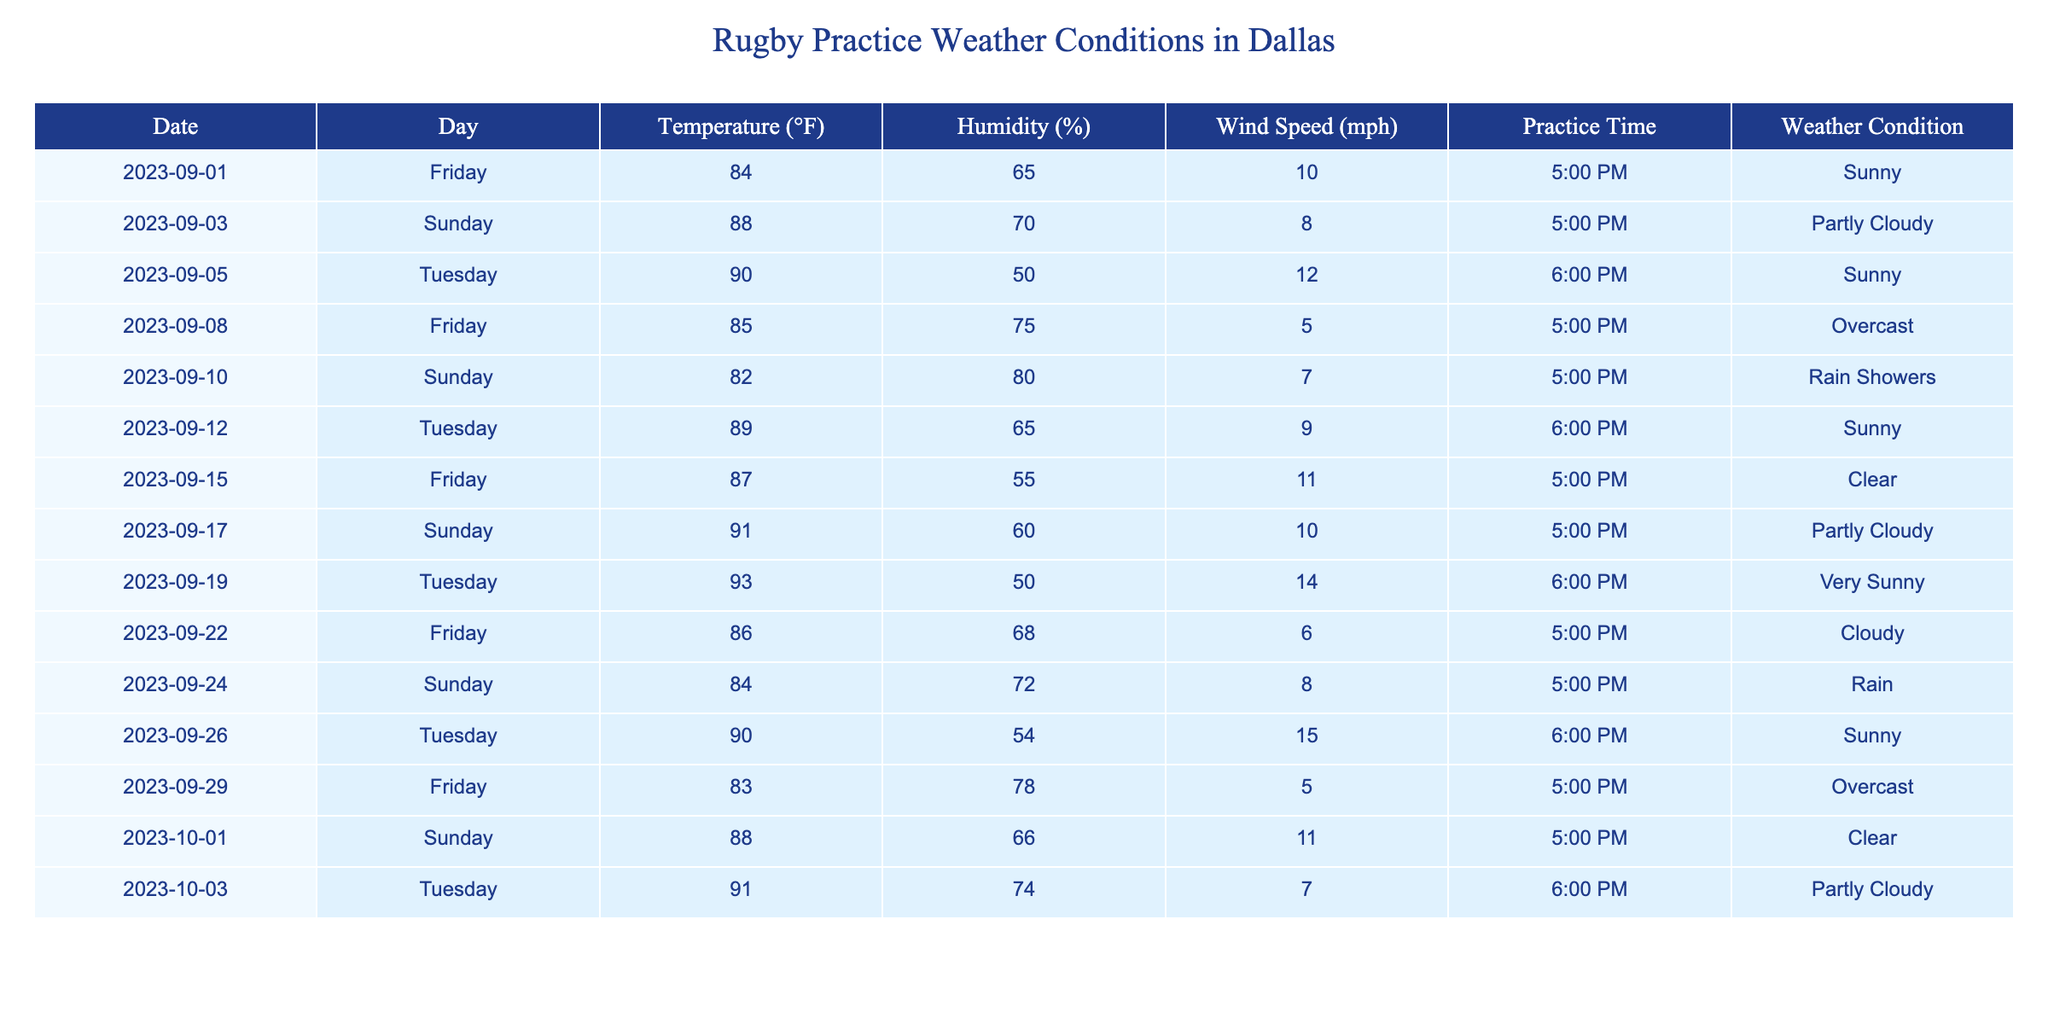What was the highest temperature recorded during rugby practice? The table lists the temperatures for various practice days. The maximum temperature is found by checking each entry, which shows that 93°F on 2023-09-19 was the highest.
Answer: 93°F How many days had rain as a weather condition during practice? Looking through the weather conditions in the table, there are two entries where 'Rain' or 'Rain Showers' is mentioned: 2023-09-10 and 2023-09-24. Hence, the total is two days.
Answer: 2 days What is the average humidity during the practices listed? To calculate the average humidity, sum all humidity values (65 + 70 + 50 + 75 + 80 + 65 + 55 + 60 + 50 + 68 + 72 + 54 + 78 + 66 + 74) which equals 1030 and then divide by the number of entries (15), yielding an average of 68.67%.
Answer: 68.67% Was there any day without wind during practice? By examining the wind speed column, no entries have a wind speed of 0 mph; each practice day has recorded wind speeds between 5 and 15 mph. Thus, the answer is no.
Answer: No Which day had the lowest temperature and what was it? Reviewing the temperature column, the lowest recorded temperature is 82°F on Sunday, 2023-09-10.
Answer: 82°F On average, how much did the wind speed increase on Fridays compared to Sundays? To find the average wind speed for Fridays, add their wind speeds (10 + 5 + 11 + 6 + 5 = 37) and divide by the 5 Fridays for an average of 7.4 mph. For Sundays, the sum (8 + 10 + 14 + 8 + 11) is 51, and the average for 5 Sundays is 10.2 mph. The difference is 10.2 - 7.4 = 2.8 mph.
Answer: 2.8 mph Was there a practice day with clear weather that also had temperatures above 85°F? Checking both the weather condition and temperature, there are two days with clear weather (2023-09-15 at 87°F and 2023-10-01 at 88°F). Both entries meet the criteria.
Answer: Yes What was the most common weather condition during practices? Counting the occurrences for each weather condition, Sunny appears 5 times, Overcast 2 times, Partly Cloudy 3 times, Clear 2 times, and Rain/Rain Showers 2 times. Sunny is the most common condition.
Answer: Sunny Which day had the highest wind speed, and what was that speed? By checking the wind speeds, the highest is noted on 2023-09-26 with a speed of 15 mph.
Answer: 15 mph How many days had temperatures above the average temperature of 88°F? The average temperature calculated from the table is 88°F. Checking the temperature column, only 4 days (89°F, 90°F, 91°F, 93°F) exceed this average.
Answer: 4 days During which practice did we have the lowest humidity, and what was the percentage? The minimum humidity is observed on 2023-09-05 at 50%.
Answer: 50% on 2023-09-05 